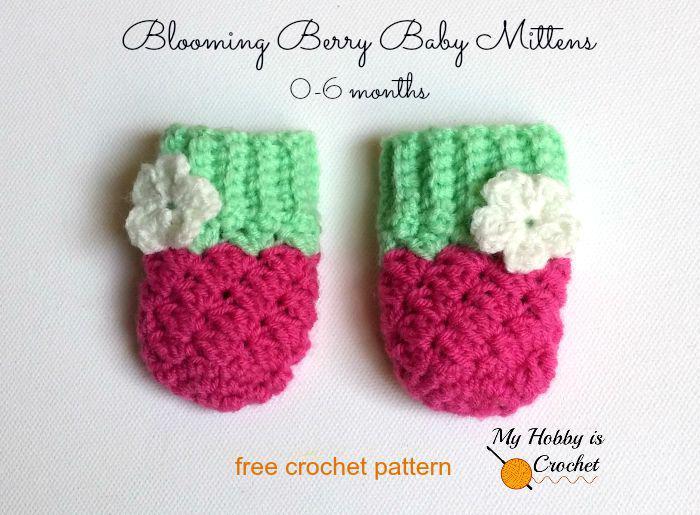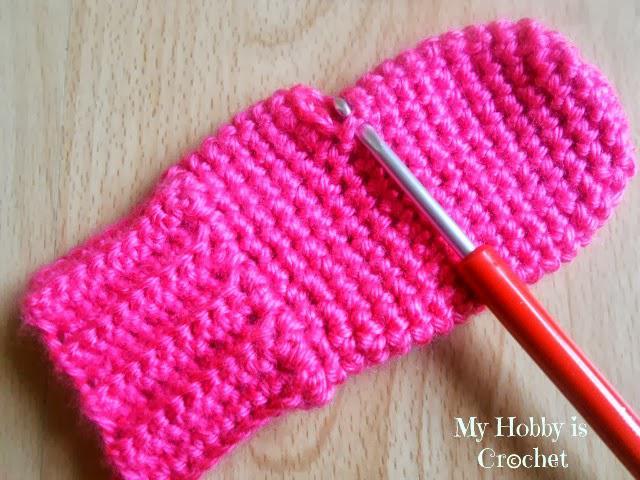The first image is the image on the left, the second image is the image on the right. Examine the images to the left and right. Is the description "Each image contains at least two baby mittens, and no mittens have separate thumb sections." accurate? Answer yes or no. No. The first image is the image on the left, the second image is the image on the right. For the images shown, is this caption "There are at least 3 pairs of mittens all a different color." true? Answer yes or no. No. 